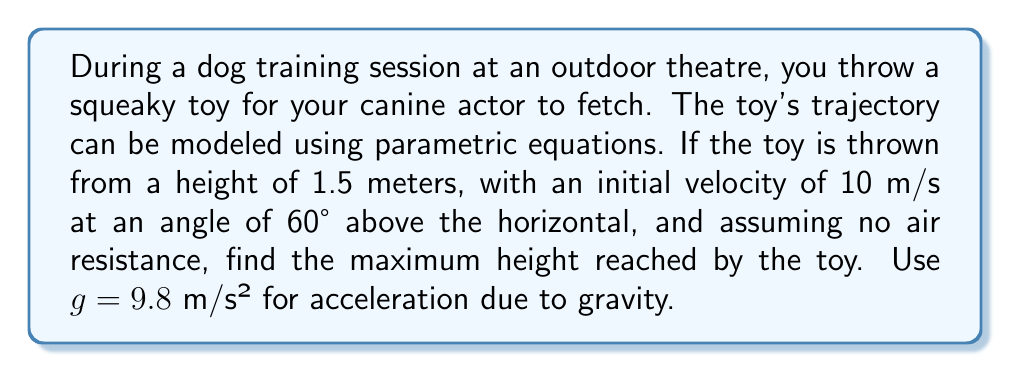Could you help me with this problem? Let's approach this step-by-step:

1) The parametric equations for projectile motion are:
   $$x(t) = v_0 \cos(\theta) t$$
   $$y(t) = v_0 \sin(\theta) t - \frac{1}{2}gt^2 + y_0$$

   Where:
   $v_0$ = initial velocity
   $\theta$ = angle of projection
   $g$ = acceleration due to gravity
   $y_0$ = initial height

2) Given:
   $v_0 = 10$ m/s
   $\theta = 60°$
   $g = 9.8$ m/s²
   $y_0 = 1.5$ m

3) To find the maximum height, we need to find when the vertical velocity is zero:
   $$\frac{dy}{dt} = v_0 \sin(\theta) - gt = 0$$

4) Solve for t:
   $$t = \frac{v_0 \sin(\theta)}{g}$$

5) Substitute the values:
   $$t = \frac{10 \sin(60°)}{9.8} = \frac{10 \cdot \frac{\sqrt{3}}{2}}{9.8} \approx 0.884 \text{ seconds}$$

6) Now, substitute this t back into the equation for y(t):
   $$y(0.884) = 10 \sin(60°) \cdot 0.884 - \frac{1}{2} \cdot 9.8 \cdot 0.884^2 + 1.5$$

7) Simplify:
   $$y(0.884) = 10 \cdot \frac{\sqrt{3}}{2} \cdot 0.884 - 4.9 \cdot 0.781 + 1.5 \approx 5.33 \text{ meters}$$

Therefore, the maximum height reached by the toy is approximately 5.33 meters.
Answer: $5.33$ meters 